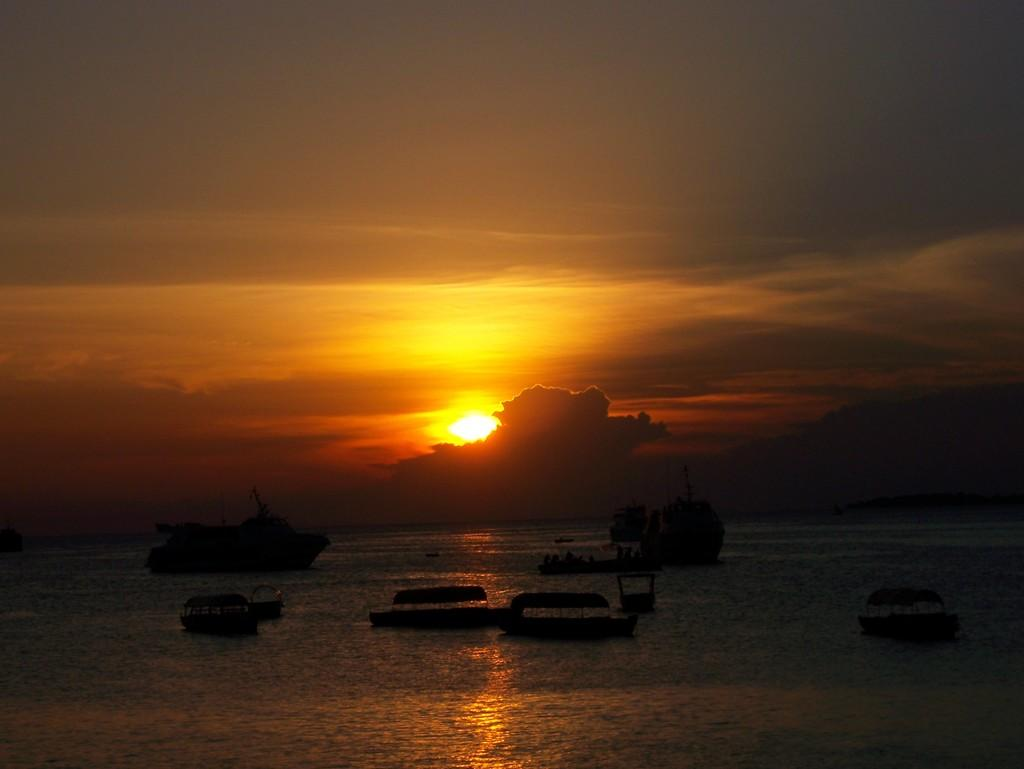What is the main subject of the image? The main subject of the image is boats. Where are the boats located? The boats are on the water. What can be seen in the background of the image? There are trees, the sun, and the sky visible in the background of the image. Can you describe the bite marks on the body of the bat in the image? There is no bat or body with bite marks present in the image; it features boats on the water with trees, the sun, and the sky in the background. 